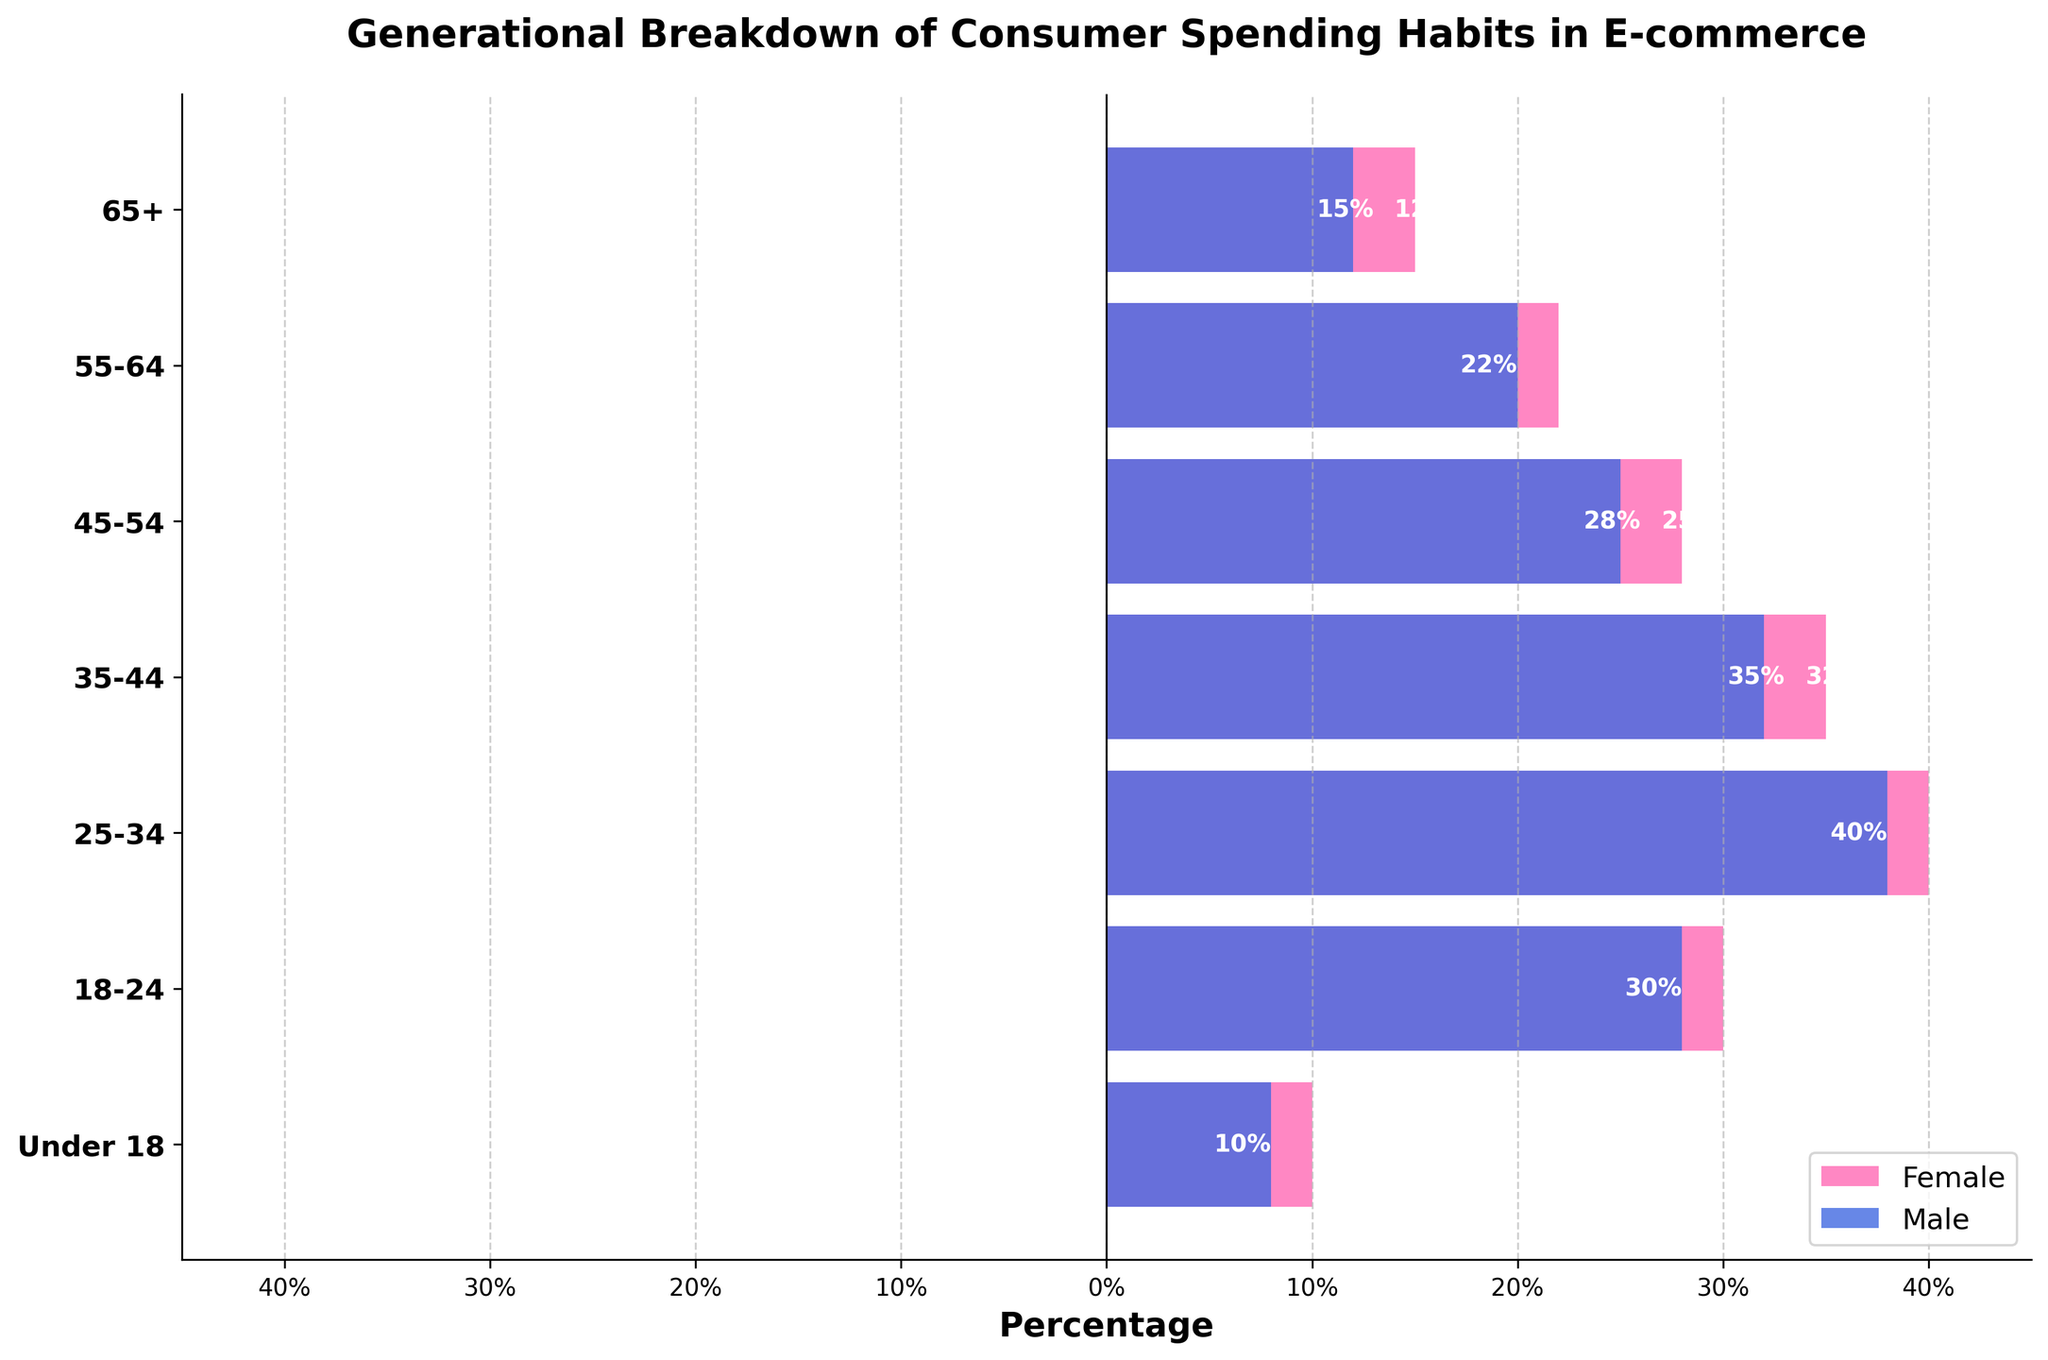What's the title of the figure? The title is usually displayed at the top of the figure and provides a summary of what the figure is about. In this case, it can be seen at the top of the plot.
Answer: Generational Breakdown of Consumer Spending Habits in E-commerce How are male and female represented in the figure? By looking at the color and the legend, it shows that females are represented in pink bars on the left, and males are represented in blue bars on the right.
Answer: Pink bars for females on the left, and blue bars for males on the right Which age group has the highest spending for males? By examining the length of the blue bars, the longest blue bar can be seen in the 25-34 age group.
Answer: 25-34 What's the percentage of female spending in the 35-44 age group? By reading the length of the pink bar corresponding to the 35-44 age group, the figure shows -35%.
Answer: 35% What is the combined percentage of spending for both males and females in the Under 18 age group? Find the percentages for males and females in the Under 18 category (8% for males and 10% for females), then sum them up: 8% + 10% = 18%.
Answer: 18% Is there any age group where female spending is more than male spending? The labels and bar lengths should be checked; the figure shows that in all cases, the male percentage is higher or equal compared to the female percentage.
Answer: No What is the difference in spending between males and females in the 55-64 age group? Subtract the female percentage from the male percentage for the 55-64 age group (20% - 22% = -2%).
Answer: -2% Which age group shows the least female spending, and what is the percentage? By comparing the length of the pink bars across all age groups, the Under 18 age group shows the smallest percentage (-10%).
Answer: Under 18, 10% How does spending in the 45-54 age group compare between genders? Compare the lengths from the axis (pink bar is -28% and blue bar is 25%).
Answer: Female: 28%, Male: 25% Is there a noticeable trend in spending habits across different age groups? Looking from youngest to oldest, female spending increases then decreases, while male spending steadily increases with age group variations.
Answer: Female: fluctuating, Male: increasing with age 